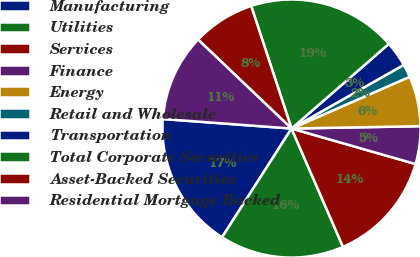<chart> <loc_0><loc_0><loc_500><loc_500><pie_chart><fcel>Manufacturing<fcel>Utilities<fcel>Services<fcel>Finance<fcel>Energy<fcel>Retail and Wholesale<fcel>Transportation<fcel>Total Corporate Securities<fcel>Asset-Backed Securities<fcel>Residential Mortgage Backed<nl><fcel>17.13%<fcel>15.58%<fcel>14.03%<fcel>4.73%<fcel>6.28%<fcel>1.64%<fcel>3.18%<fcel>18.67%<fcel>7.83%<fcel>10.93%<nl></chart> 